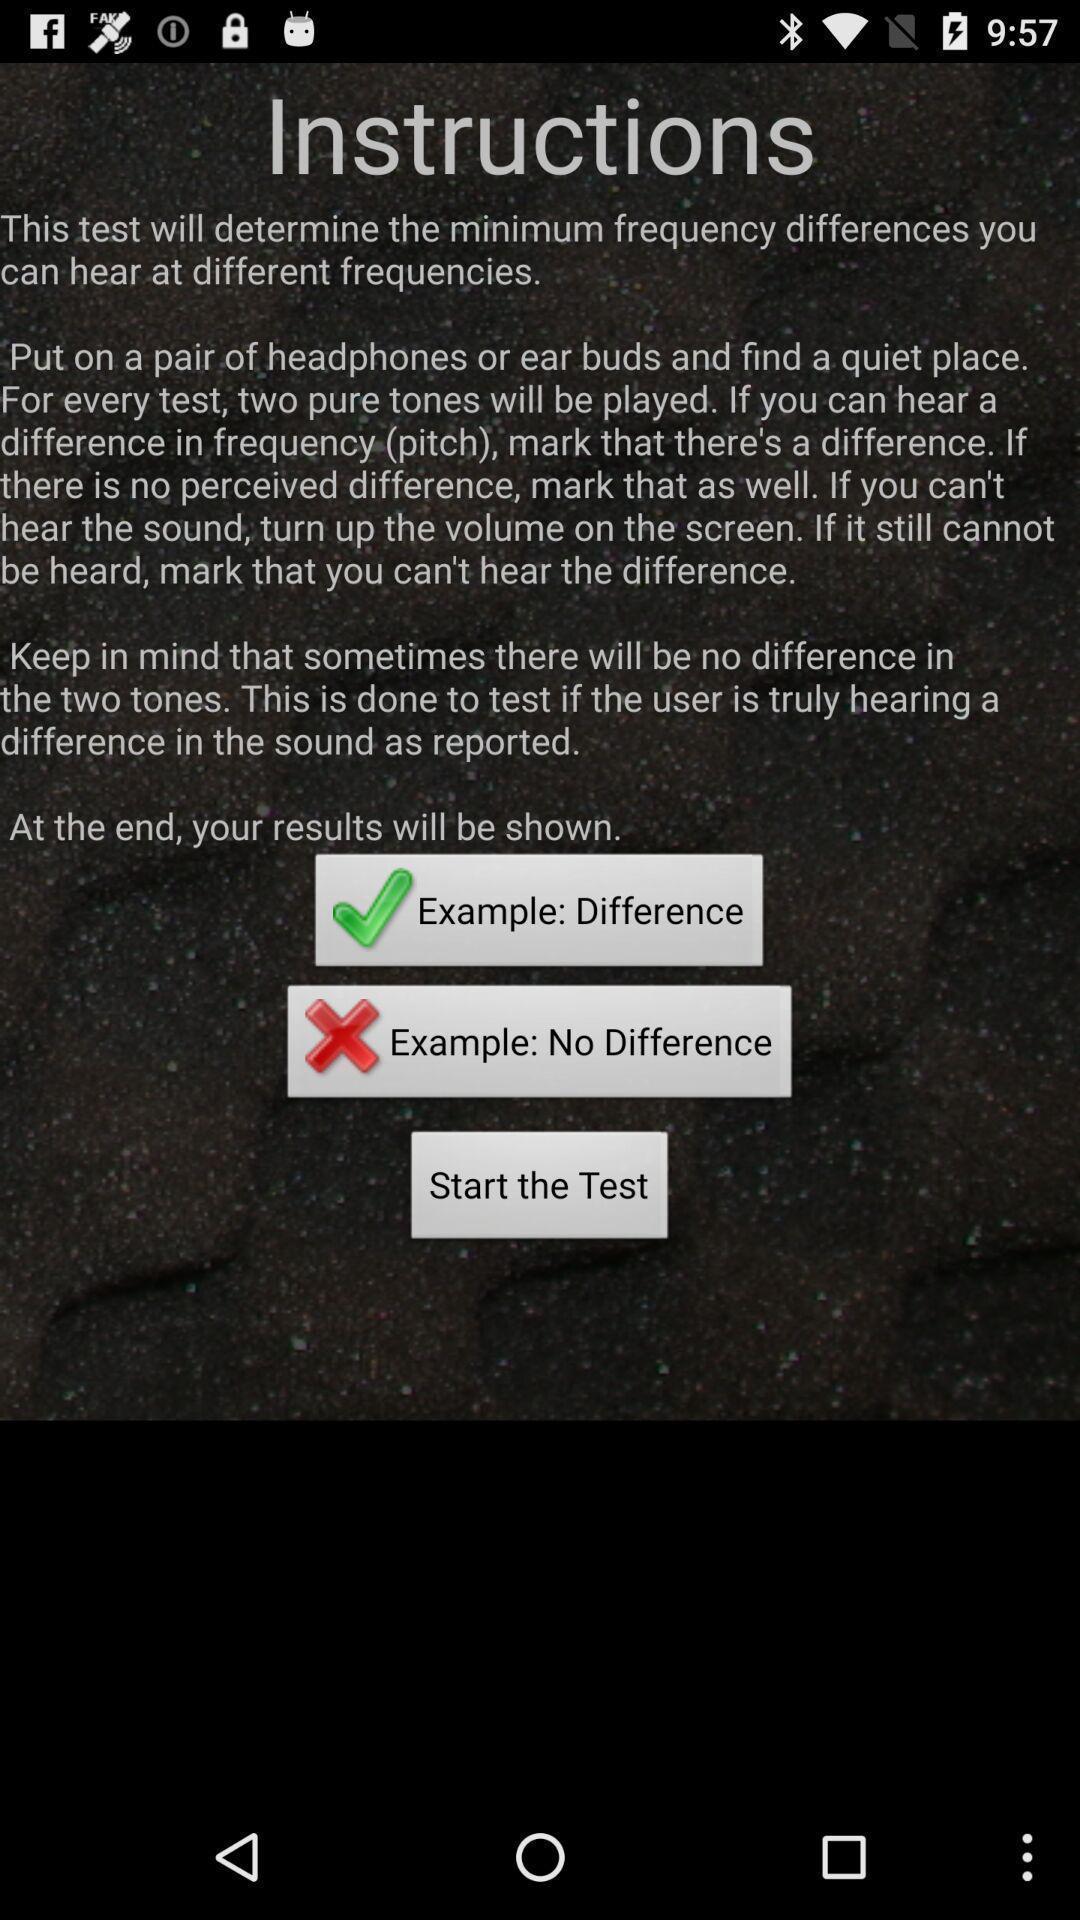Give me a summary of this screen capture. Screen showing instructions s. 